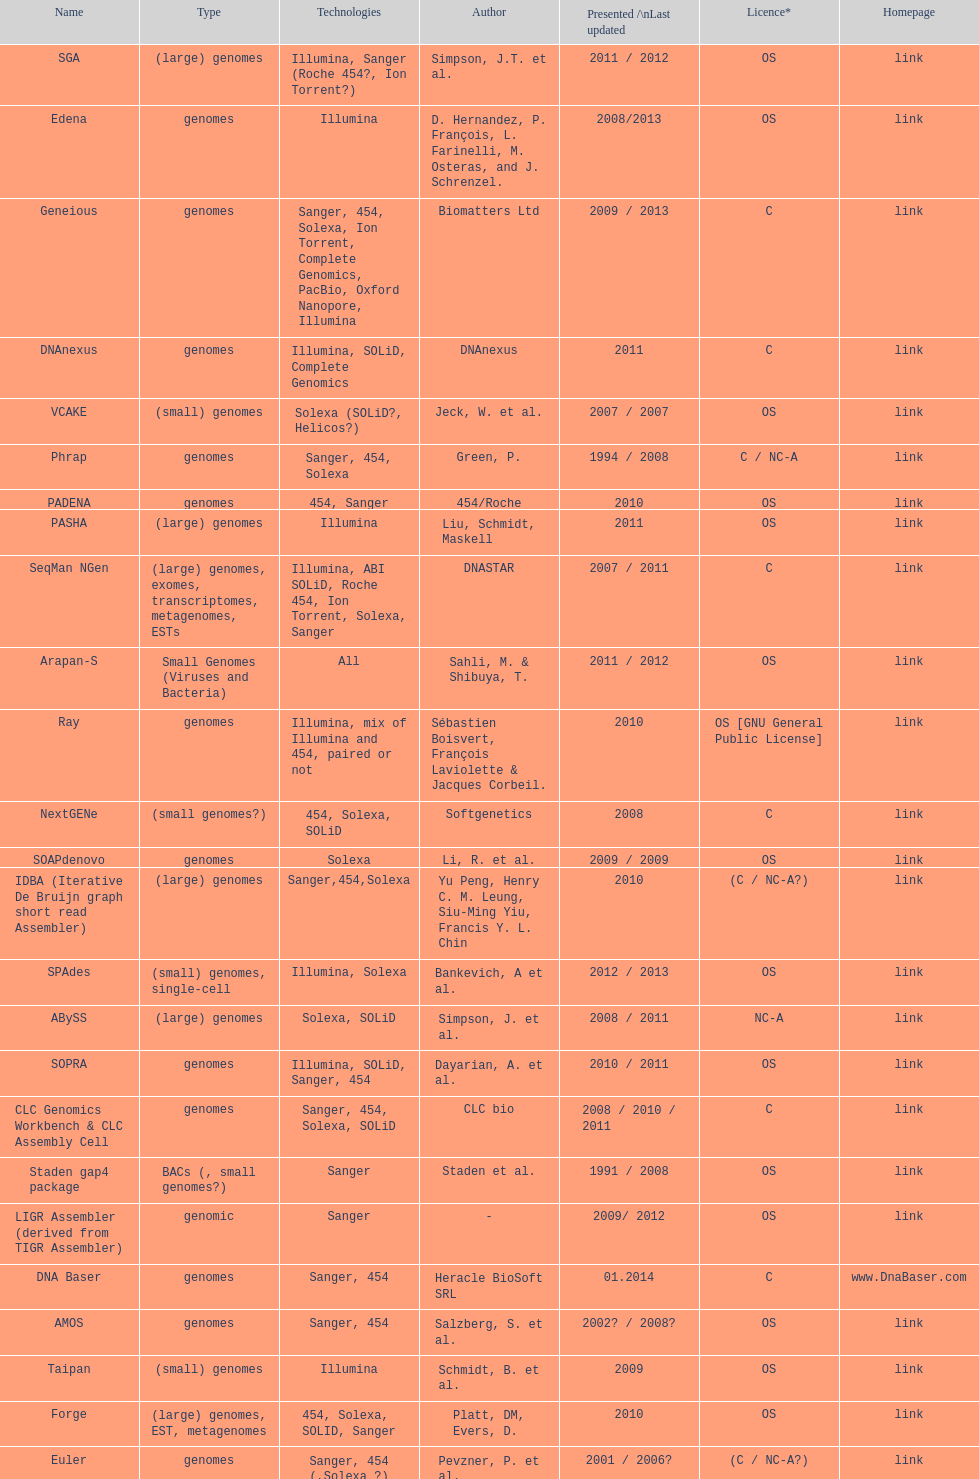When was the velvet last updated? 2009. 